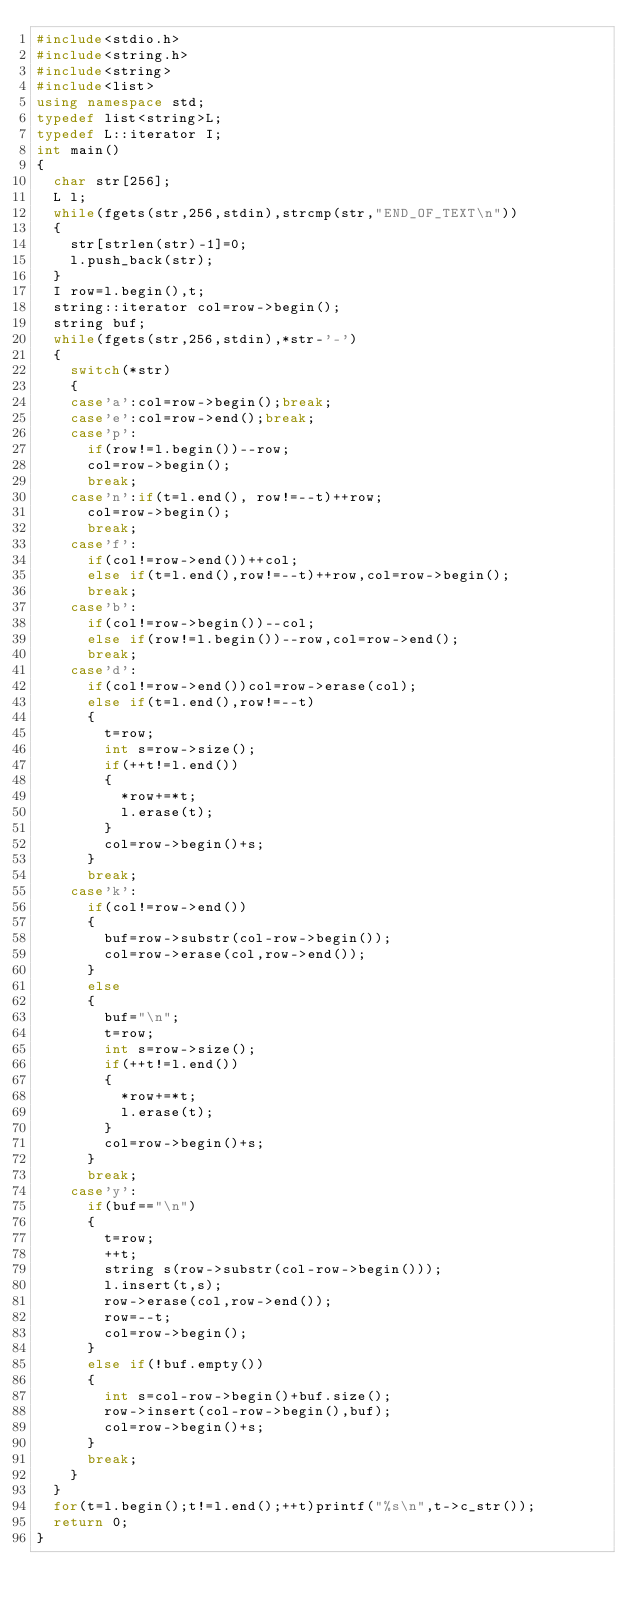<code> <loc_0><loc_0><loc_500><loc_500><_C++_>#include<stdio.h>
#include<string.h>
#include<string>
#include<list>
using namespace std;
typedef list<string>L;
typedef L::iterator I;
int main()
{
	char str[256];
	L l;
	while(fgets(str,256,stdin),strcmp(str,"END_OF_TEXT\n"))
	{
		str[strlen(str)-1]=0;
		l.push_back(str);
	}
	I row=l.begin(),t;
	string::iterator col=row->begin();
	string buf;
	while(fgets(str,256,stdin),*str-'-')
	{
		switch(*str)
		{
		case'a':col=row->begin();break;
		case'e':col=row->end();break;
		case'p':
			if(row!=l.begin())--row;
			col=row->begin();
			break;
		case'n':if(t=l.end(), row!=--t)++row;
			col=row->begin();
			break;
		case'f':
			if(col!=row->end())++col;
			else if(t=l.end(),row!=--t)++row,col=row->begin();
			break;
		case'b':
			if(col!=row->begin())--col;
			else if(row!=l.begin())--row,col=row->end();
			break;
		case'd':
			if(col!=row->end())col=row->erase(col);
			else if(t=l.end(),row!=--t)
			{
				t=row;
				int s=row->size();
				if(++t!=l.end())
				{
					*row+=*t;
					l.erase(t);
				}
				col=row->begin()+s;
			}
			break;
		case'k':
			if(col!=row->end())
			{
				buf=row->substr(col-row->begin());
				col=row->erase(col,row->end());
			}
			else
			{
				buf="\n";
				t=row;
				int s=row->size();
				if(++t!=l.end())
				{
					*row+=*t;
					l.erase(t);
				}
				col=row->begin()+s;
			}
			break;
		case'y':
			if(buf=="\n")
			{
				t=row;
				++t;
				string s(row->substr(col-row->begin()));
				l.insert(t,s);
				row->erase(col,row->end());
				row=--t;
				col=row->begin();
			}
			else if(!buf.empty())
			{
				int s=col-row->begin()+buf.size();
				row->insert(col-row->begin(),buf);
				col=row->begin()+s;
			}
			break;
		}
	}
	for(t=l.begin();t!=l.end();++t)printf("%s\n",t->c_str());
	return 0;
}</code> 